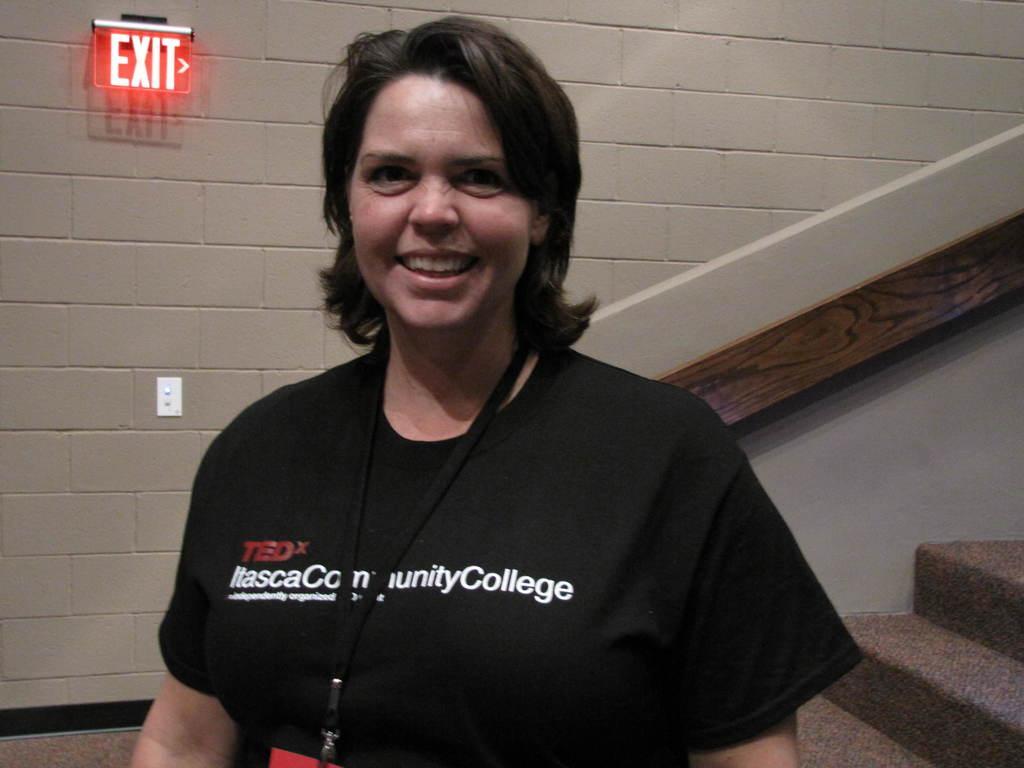Describe this image in one or two sentences. In this image we can see a lady wearing a tag. In the back there is a wall with exit board. On the right side there are steps with side wall. 